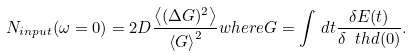<formula> <loc_0><loc_0><loc_500><loc_500>N _ { i n p u t } ( \omega = 0 ) = 2 D \frac { \left \langle ( \Delta G ) ^ { 2 } \right \rangle } { \left \langle G \right \rangle ^ { 2 } } w h e r e G = \int \, d t \frac { \delta E ( t ) } { \delta \ t h d ( 0 ) } .</formula> 